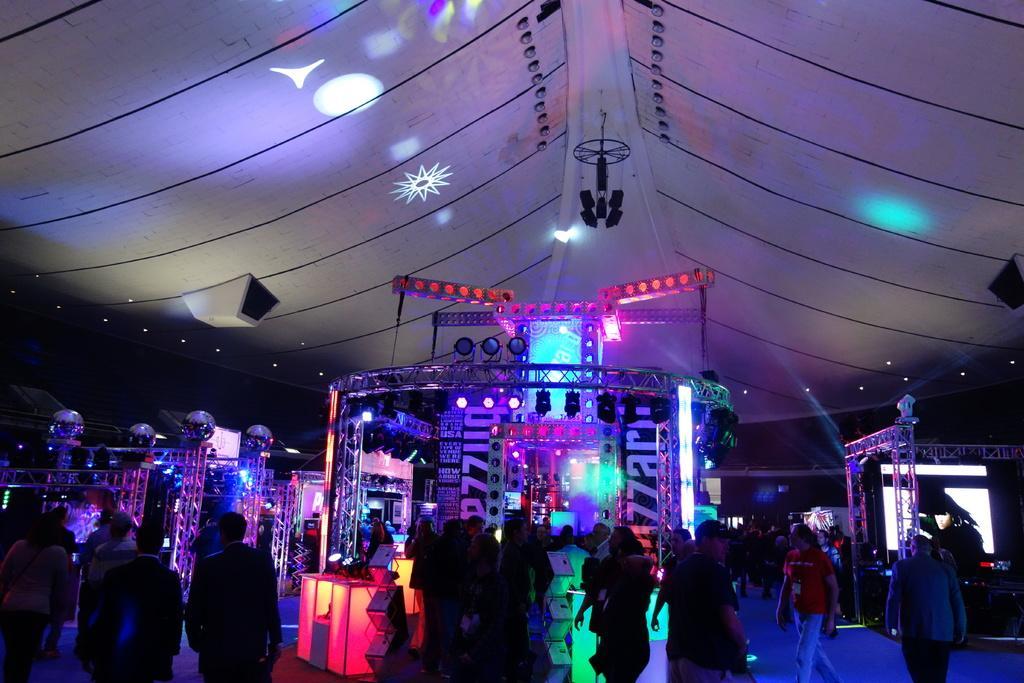Please provide a concise description of this image. The image is taken inside the tent. In the center of the image we can see stalls. At the bottom there are people walking. We can see lights. 